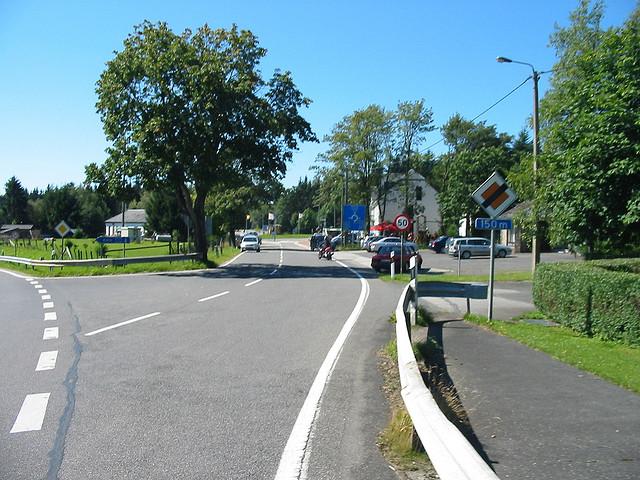What color is the street?
Answer briefly. Gray. Which way does the road turn?
Give a very brief answer. Right. Is it daytime?
Keep it brief. Yes. 